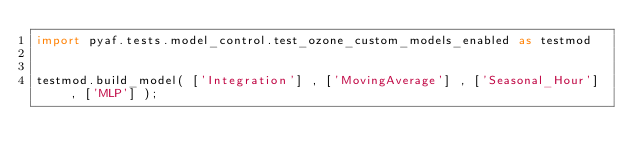<code> <loc_0><loc_0><loc_500><loc_500><_Python_>import pyaf.tests.model_control.test_ozone_custom_models_enabled as testmod


testmod.build_model( ['Integration'] , ['MovingAverage'] , ['Seasonal_Hour'] , ['MLP'] );</code> 